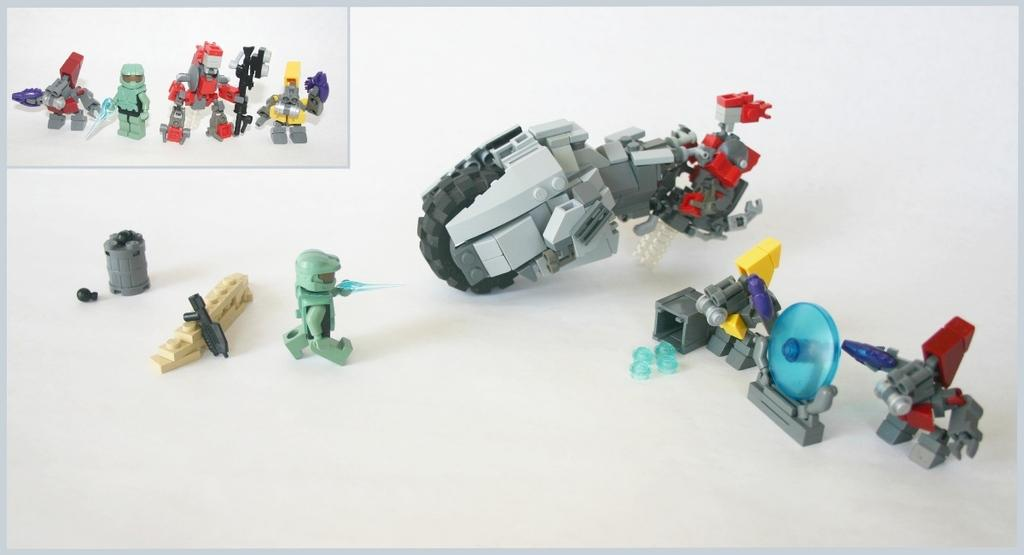What objects can be seen in the image? There are toys in the image. What color is the background of the image? The background of the image is white. What type of magic can be performed with the toys in the image? There is no magic or any indication of magical abilities in the image; it simply shows toys on a white background. 